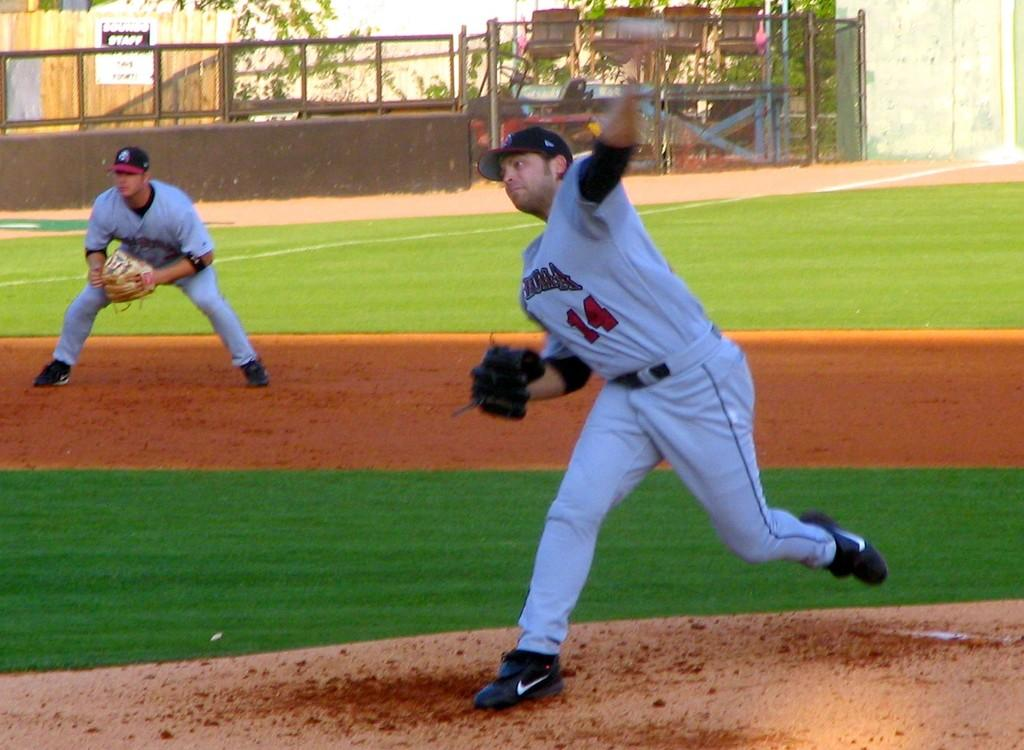<image>
Create a compact narrative representing the image presented. Two men playing baseball and number 14 is throwing a pitch. 